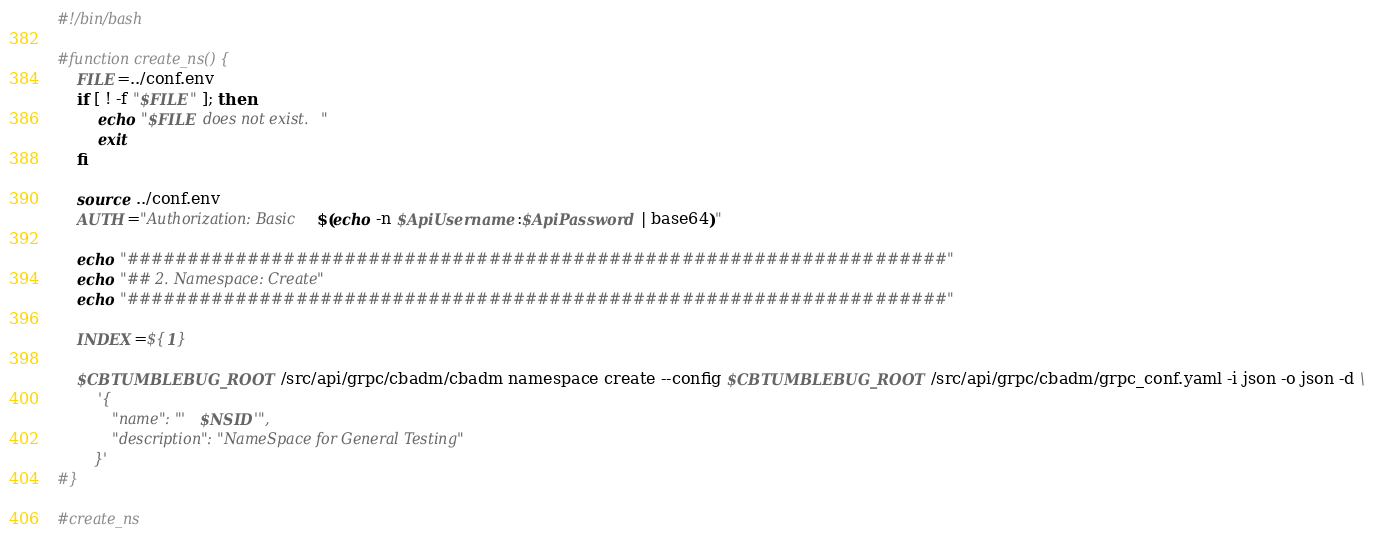<code> <loc_0><loc_0><loc_500><loc_500><_Bash_>#!/bin/bash

#function create_ns() {
    FILE=../conf.env
    if [ ! -f "$FILE" ]; then
        echo "$FILE does not exist."
        exit
    fi

	source ../conf.env
	AUTH="Authorization: Basic $(echo -n $ApiUsername:$ApiPassword | base64)"

	echo "####################################################################"
	echo "## 2. Namespace: Create"
	echo "####################################################################"

	INDEX=${1}

	$CBTUMBLEBUG_ROOT/src/api/grpc/cbadm/cbadm namespace create --config $CBTUMBLEBUG_ROOT/src/api/grpc/cbadm/grpc_conf.yaml -i json -o json -d \
		'{
			"name": "'$NSID'",
			"description": "NameSpace for General Testing"
		}' 
#}

#create_ns</code> 